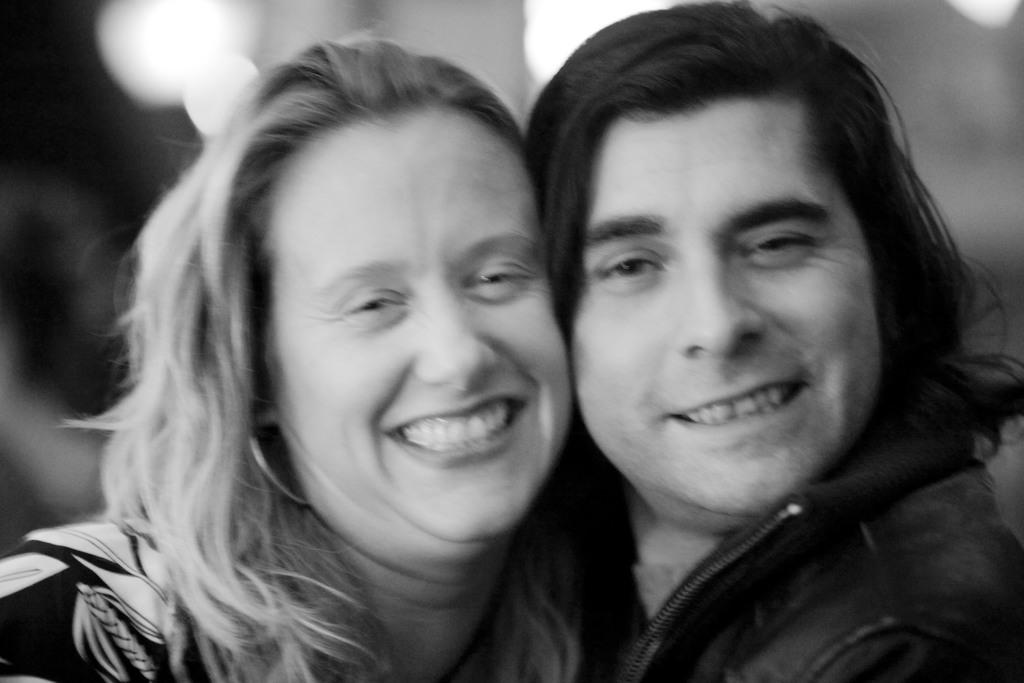How many people are in the image? There are two persons in the image. Can you describe the gender of the people in the image? One of the persons is a man, and the other person is a woman. What expressions do the people in the image have? Both the man and the woman are smiling. Are there any boots covered in cobwebs in the image? There is no mention of boots or cobwebs in the image; it features two people smiling. 